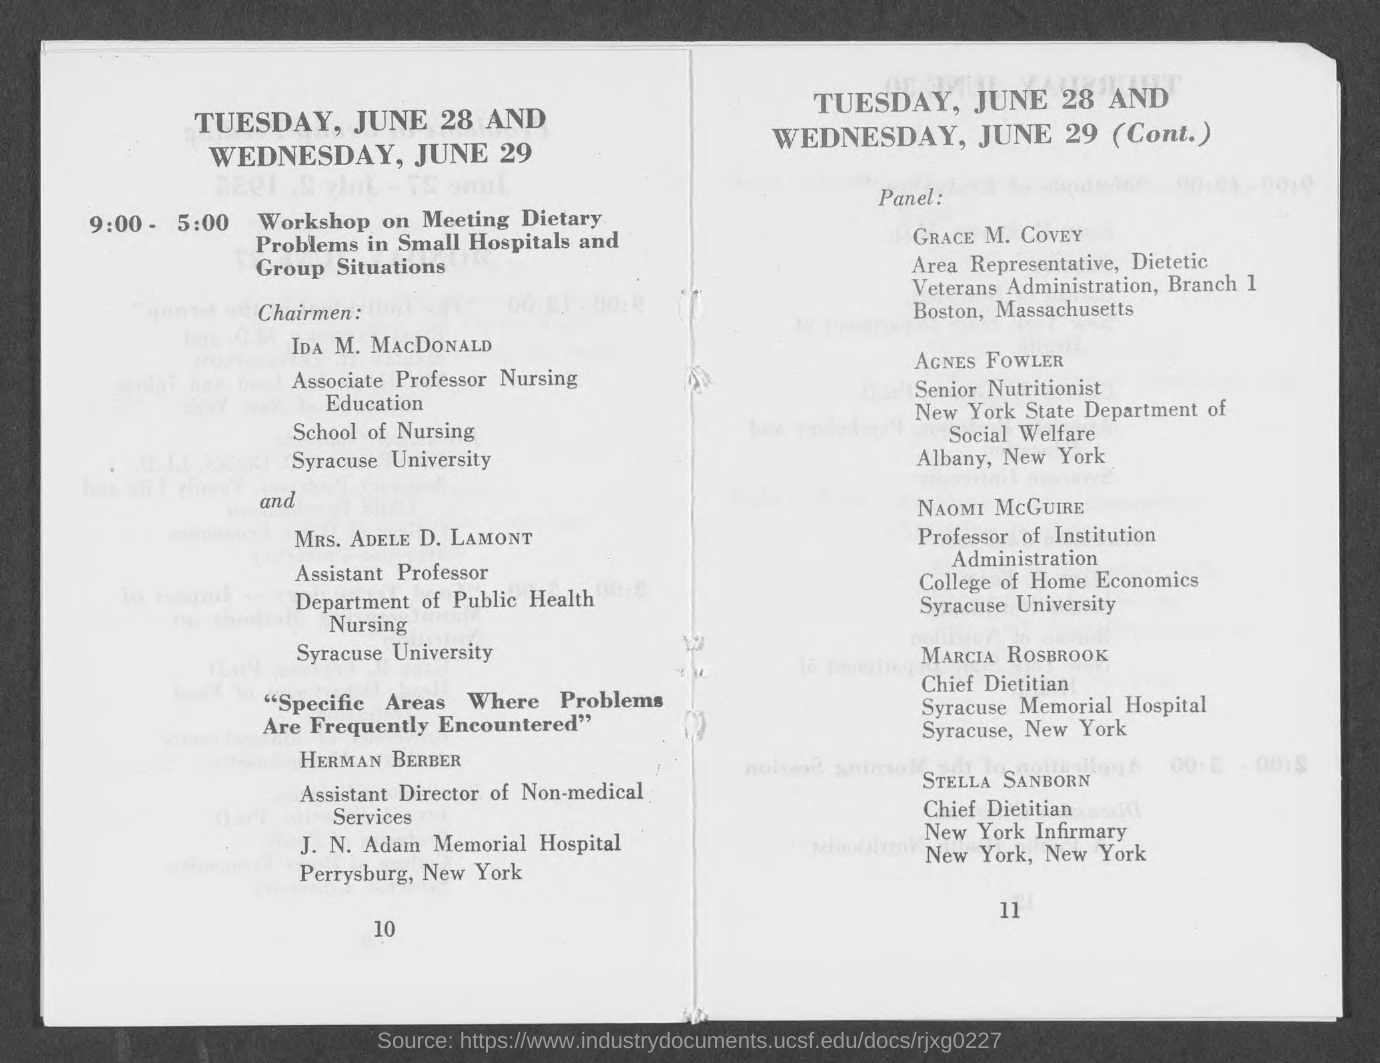When will the 'Workshop on meeting dietary problems in small hospitals and group situations' will begin ?
Provide a short and direct response. 9:00. What is the topic of the workshop conducted on June 28 at 9 am ?
Provide a short and direct response. Workshop on Meeting Dietary Problems in Small Hospitals and Group Situations. Who is the 'Chief Dietitian' of New York Infirmary?
Provide a short and direct response. Stella sanborn. Who is the "Senior Nutritionist" of New York State Department of Social Welfare Albany?
Offer a terse response. AGNES FOWLER. Who is the "Assitant Director of Non-Medical Services" of J.N Adam Memorial Hospital perrysburg ?
Ensure brevity in your answer.  HERMAN BERBER. In which university,does  NAOMI MCGUIRE works ?
Make the answer very short. Syracuse university. 